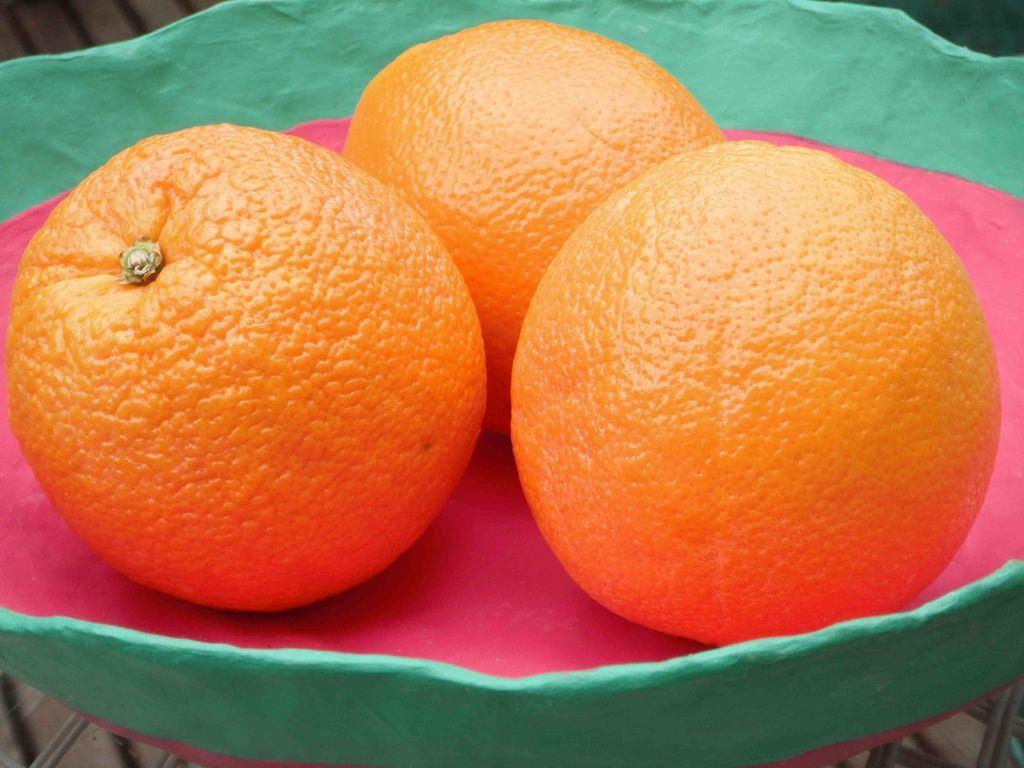In one or two sentences, can you explain what this image depicts? In this image, we can see three oranges are placed in a bowl. 